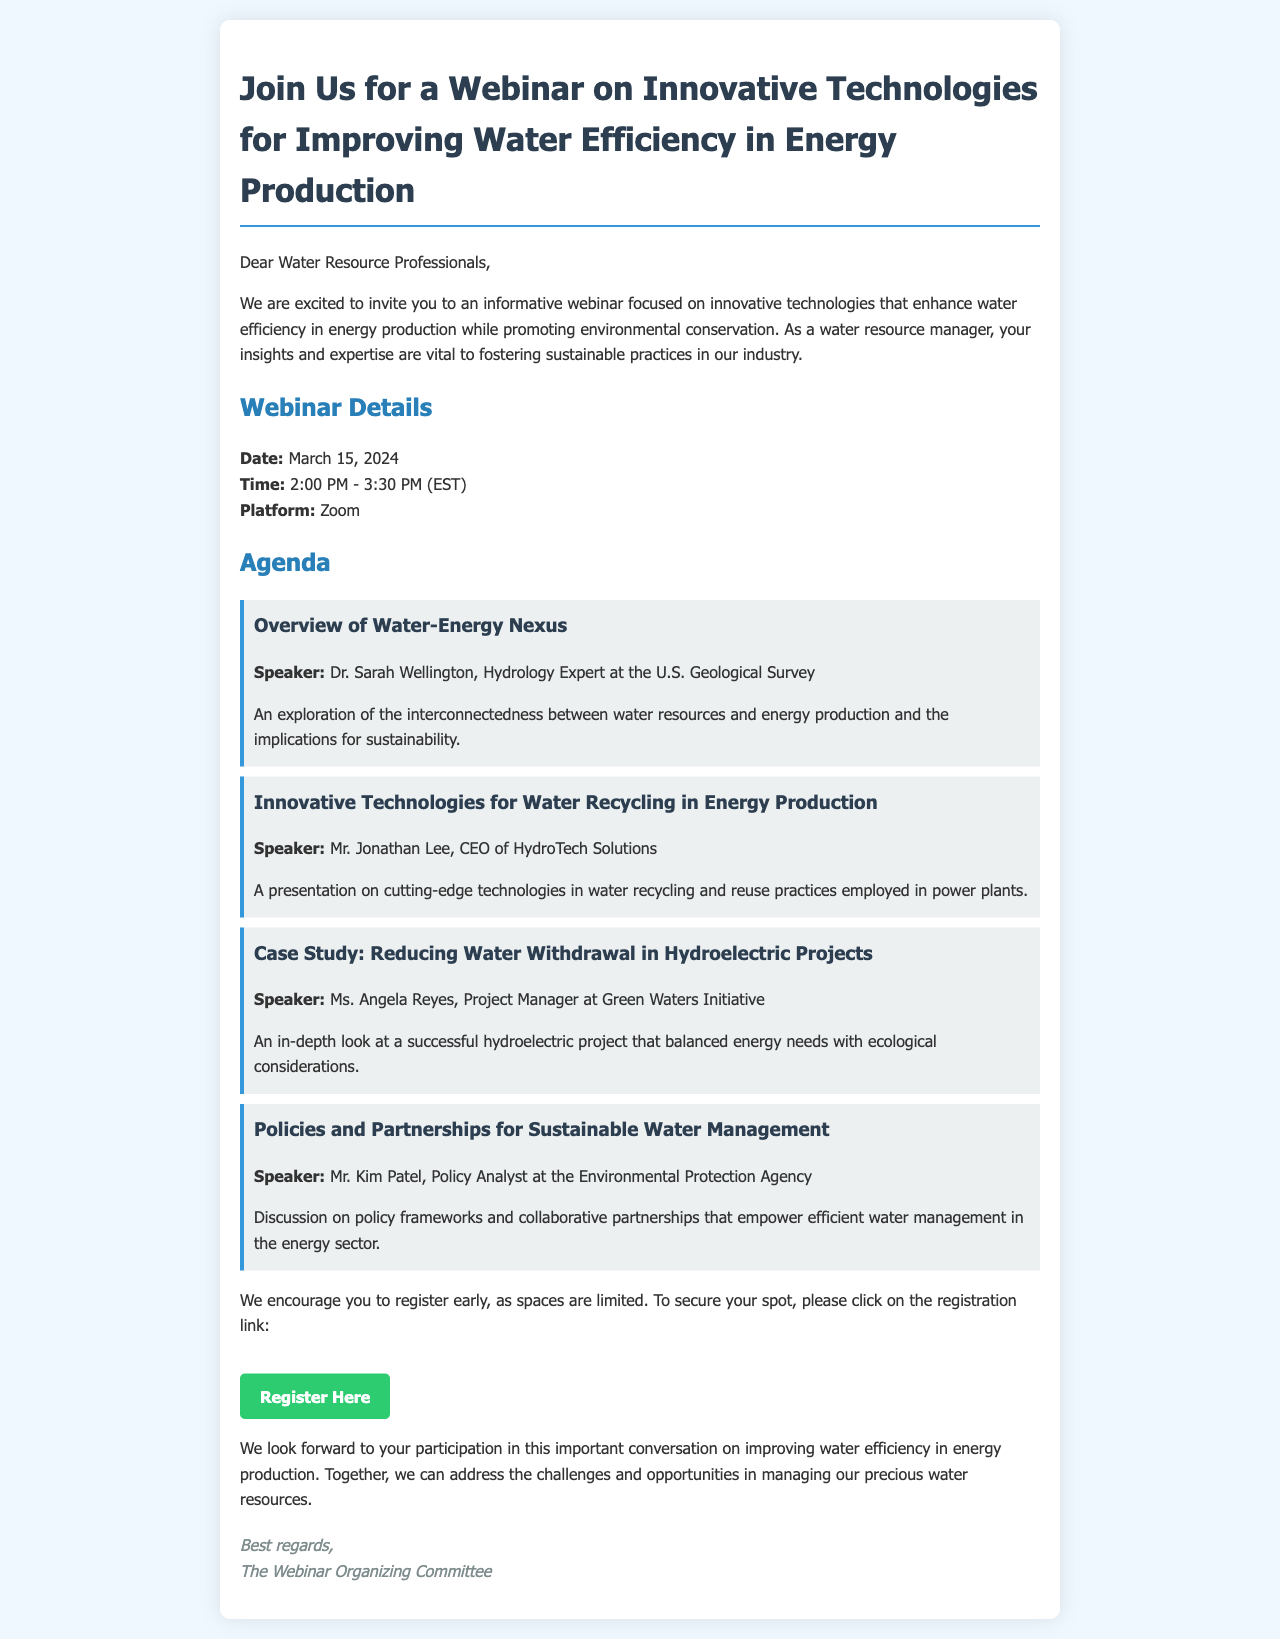What is the date of the webinar? The date of the webinar is specifically mentioned in the details section of the document.
Answer: March 15, 2024 Who is the speaker for the session on water recycling? The name of the speaker is provided in the agenda for the session on innovative technologies for water recycling.
Answer: Mr. Jonathan Lee What time does the webinar start? The start time of the webinar is outlined in the details section.
Answer: 2:00 PM What topic will Dr. Sarah Wellington discuss? The topic of Dr. Sarah Wellington's presentation is indicated in the agenda section.
Answer: Overview of Water-Energy Nexus What organization does Mr. Kim Patel work for? The organization that Mr. Kim Patel is associated with is mentioned in his introduction in the agenda.
Answer: Environmental Protection Agency How long is the webinar scheduled to last? The duration of the webinar is inferred from the timing mentioned in the details section.
Answer: 1 hour 30 minutes What is the registration link button labeled as? The label of the registration link is found in the call-to-action section of the document.
Answer: Register Here What is the primary focus of the webinar? The primary focus of the webinar is stated in the introduction paragraph.
Answer: innovative technologies for improving water efficiency in energy production 